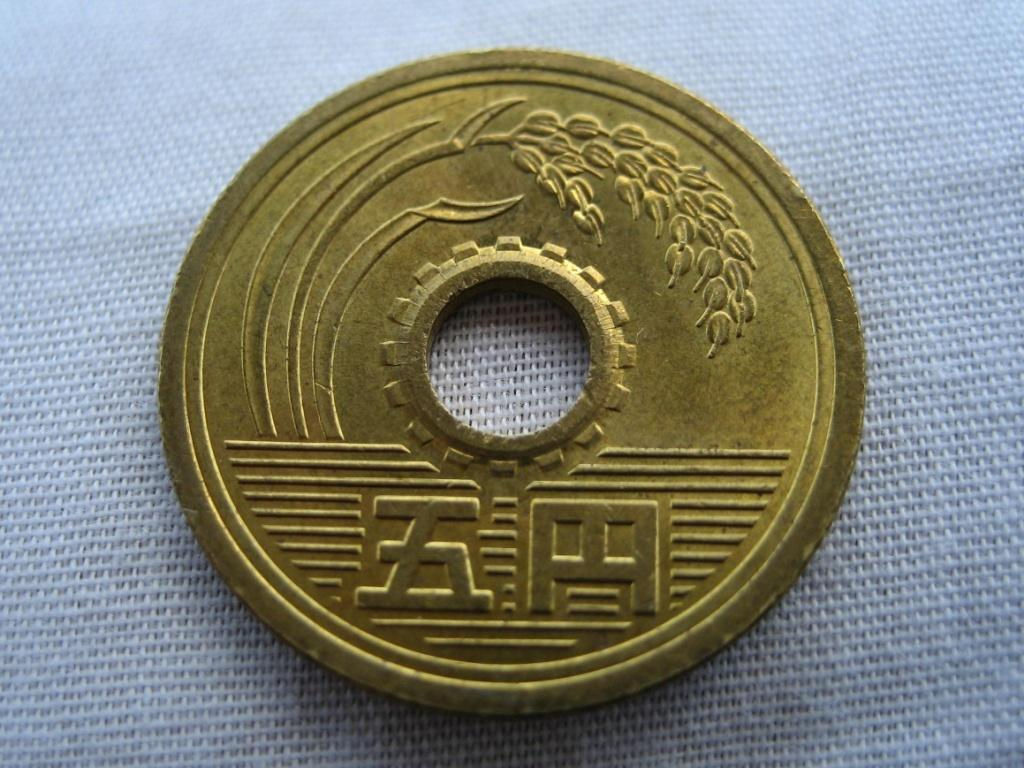What is the main subject of the image? There is a gold color coin in the center of the image. What is located at the bottom of the image? There is cloth at the bottom of the image. How many spiders are crawling on the gold color coin in the image? There are no spiders present in the image. What type of credit is associated with the gold color coin in the image? The image does not provide information about any credit associated with the coin. Is there a calculator visible in the image? There is no calculator present in the image. 